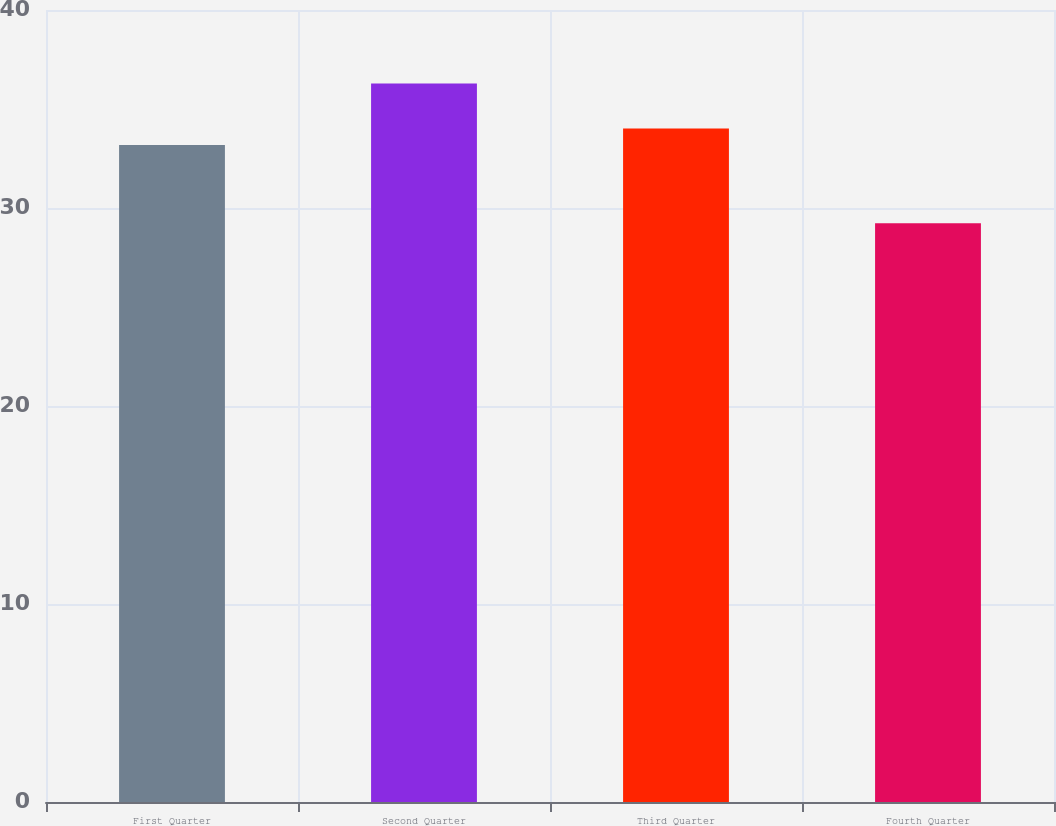Convert chart. <chart><loc_0><loc_0><loc_500><loc_500><bar_chart><fcel>First Quarter<fcel>Second Quarter<fcel>Third Quarter<fcel>Fourth Quarter<nl><fcel>33.18<fcel>36.29<fcel>34.02<fcel>29.23<nl></chart> 